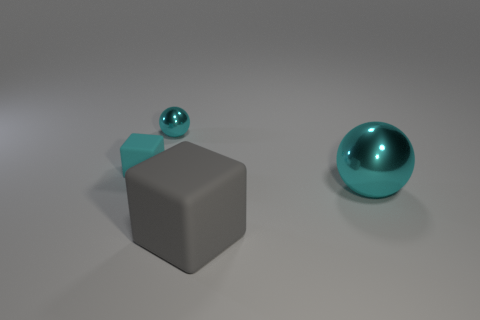How many cyan spheres must be subtracted to get 1 cyan spheres? 1 Subtract all gray blocks. Subtract all red cylinders. How many blocks are left? 1 Add 2 large red blocks. How many objects exist? 6 Add 2 metal things. How many metal things exist? 4 Subtract 0 brown blocks. How many objects are left? 4 Subtract all tiny blue objects. Subtract all large cyan objects. How many objects are left? 3 Add 1 tiny metallic things. How many tiny metallic things are left? 2 